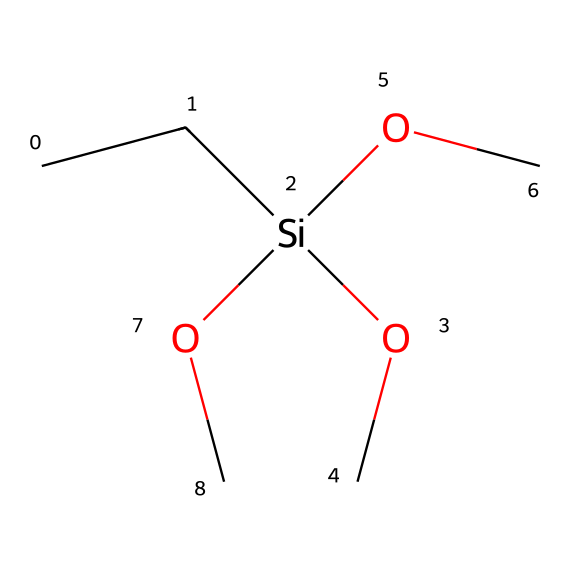What is the number of silicon atoms in this chemical? The SMILES representation indicates the presence of only one silicon atom, which is represented by the "Si" in the structure.
Answer: 1 How many oxygen atoms are present in this chemical? The chemical structure shows three instances of "O" corresponding to three oxygen atoms, which can be counted directly from the structure.
Answer: 3 What primary functional group is present in this silane? The presence of the -O (alkoxy) groups indicates that the primary functional group is an alkoxy group, which is characteristic of silanes with hydrocarbon chains.
Answer: alkoxy What is the total number of carbon atoms in this chemical? The "CC" at the beginning represents two carbon atoms attached to the silicon atom, plus three -OC groups that each contribute one carbon atom, totaling five carbon atoms.
Answer: 5 What type of reaction is typically associated with silanes in waterproofing? Silanes, when used for waterproofing, undergo hydrolysis and condensation reactions, which lead to the formation of siloxane networks that enhance water resistance.
Answer: hydrolysis Does this silane have any methyl groups? The "CC" at the beginning represents methyl groups (specifically one methyl group attached to a silicon atom), indicating that it does contain methyl groups in its structure.
Answer: yes How many total hydrogen atoms are associated with this silane? Each carbon in the structure has enough hydrogen atoms to satisfy its tetravalency, leading to a calculation of total hydrogen atoms as follows: 5 carbons each support 3 hydrogens and the silane contributes to keeping the molecule stable; this results in a total of 16 hydrogen atoms.
Answer: 16 